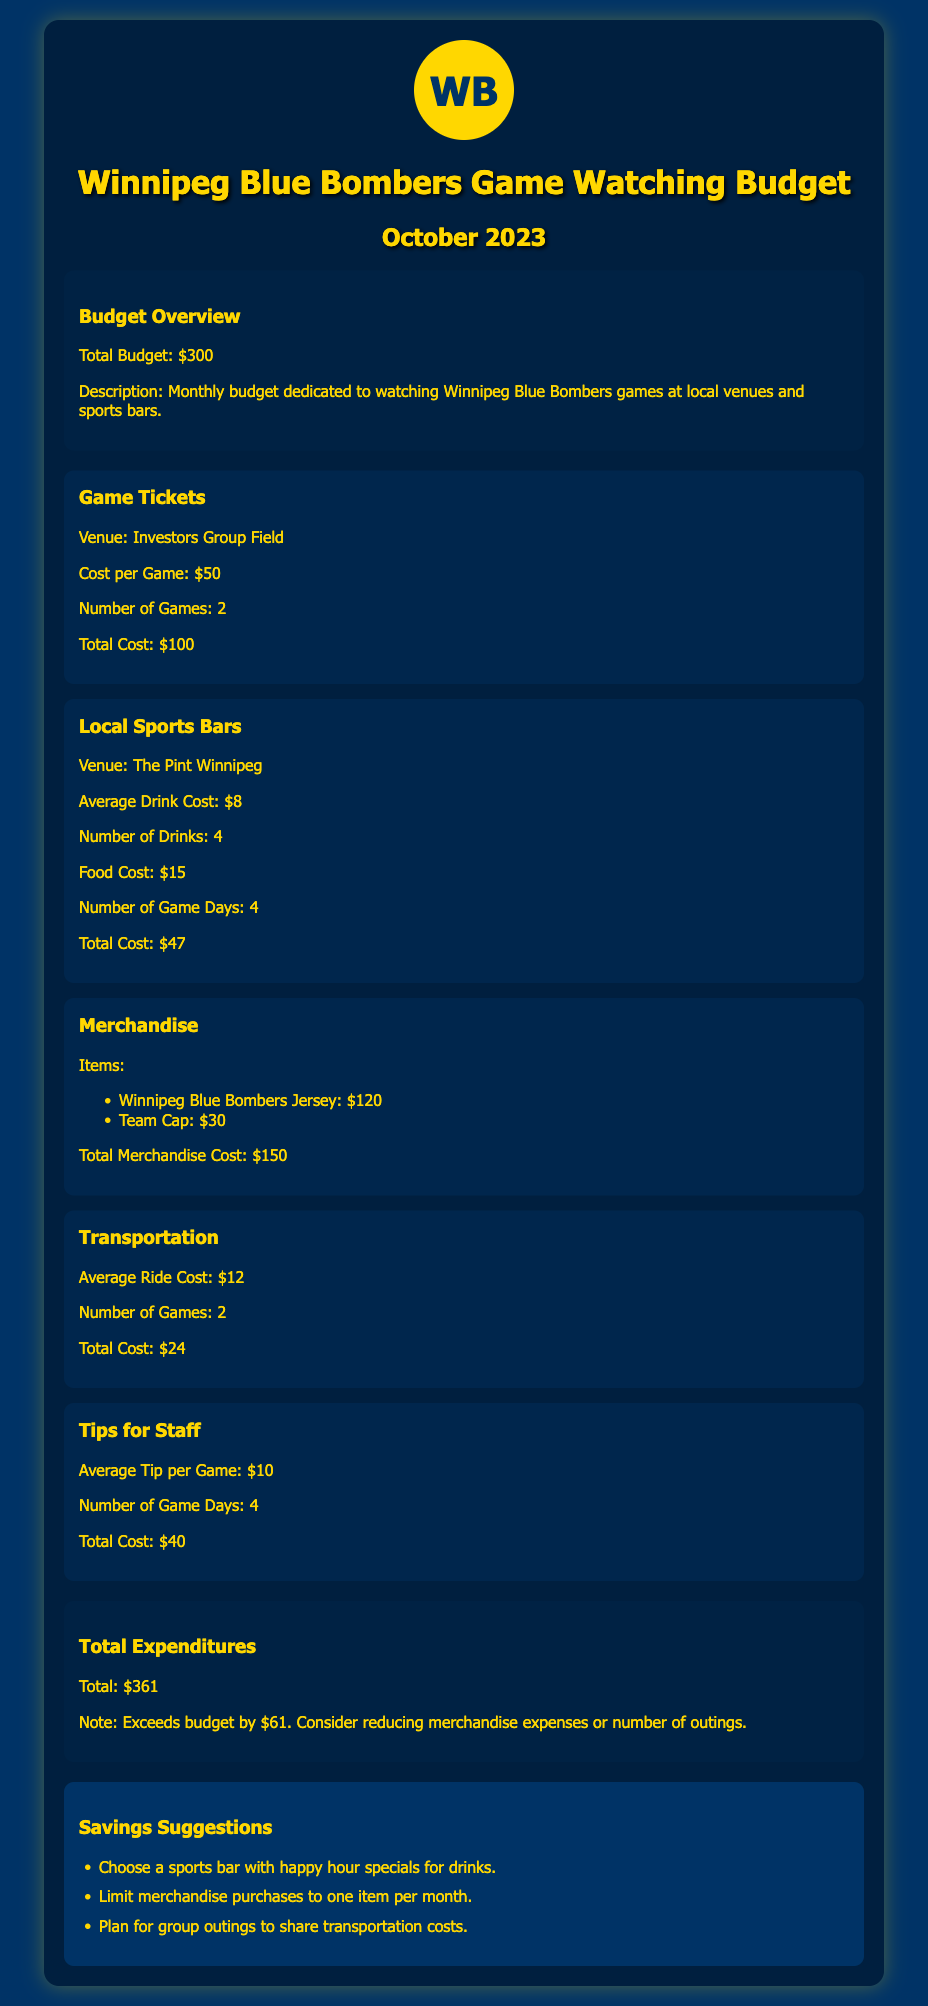what is the total budget? The total budget dedicated to watching Winnipeg Blue Bombers games is stated in the document.
Answer: $300 how much are the game tickets? The cost per game ticket for Winnipeg Blue Bombers games is detailed in the document.
Answer: $50 how many drinks are ordered at the sports bar? The number of drinks consumed at The Pint Winnipeg during game days is mentioned in the expenditure section.
Answer: 4 what is the total merchandise cost? The total cost of merchandise is calculated based on the listed items and their prices in the document.
Answer: $150 how much does transportation cost? The total cost for transportation is calculated based on the average ride cost and number of games.
Answer: $24 what is the total expenditure? The total of all expenditures combined is highlighted in the budget document.
Answer: $361 how much does the budget exceed? The note in the total expenditures section specifies how much the costs exceed the budget.
Answer: $61 how many game days are included for tips? The document specifies the number of game days considered for tips.
Answer: 4 what is one suggested saving strategy? The savings suggestions section offers advice on reducing expenses.
Answer: Choose a sports bar with happy hour specials for drinks 